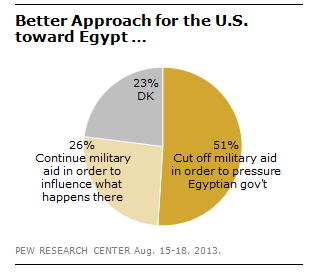Give some essential details in this illustration. In response to the question of cutting off military aid to pressure the Egyptian government, 51% of respondents support this action. The number of times military aid has been cut off is greater than the number of times military aid has continued, at 1.96 times. 